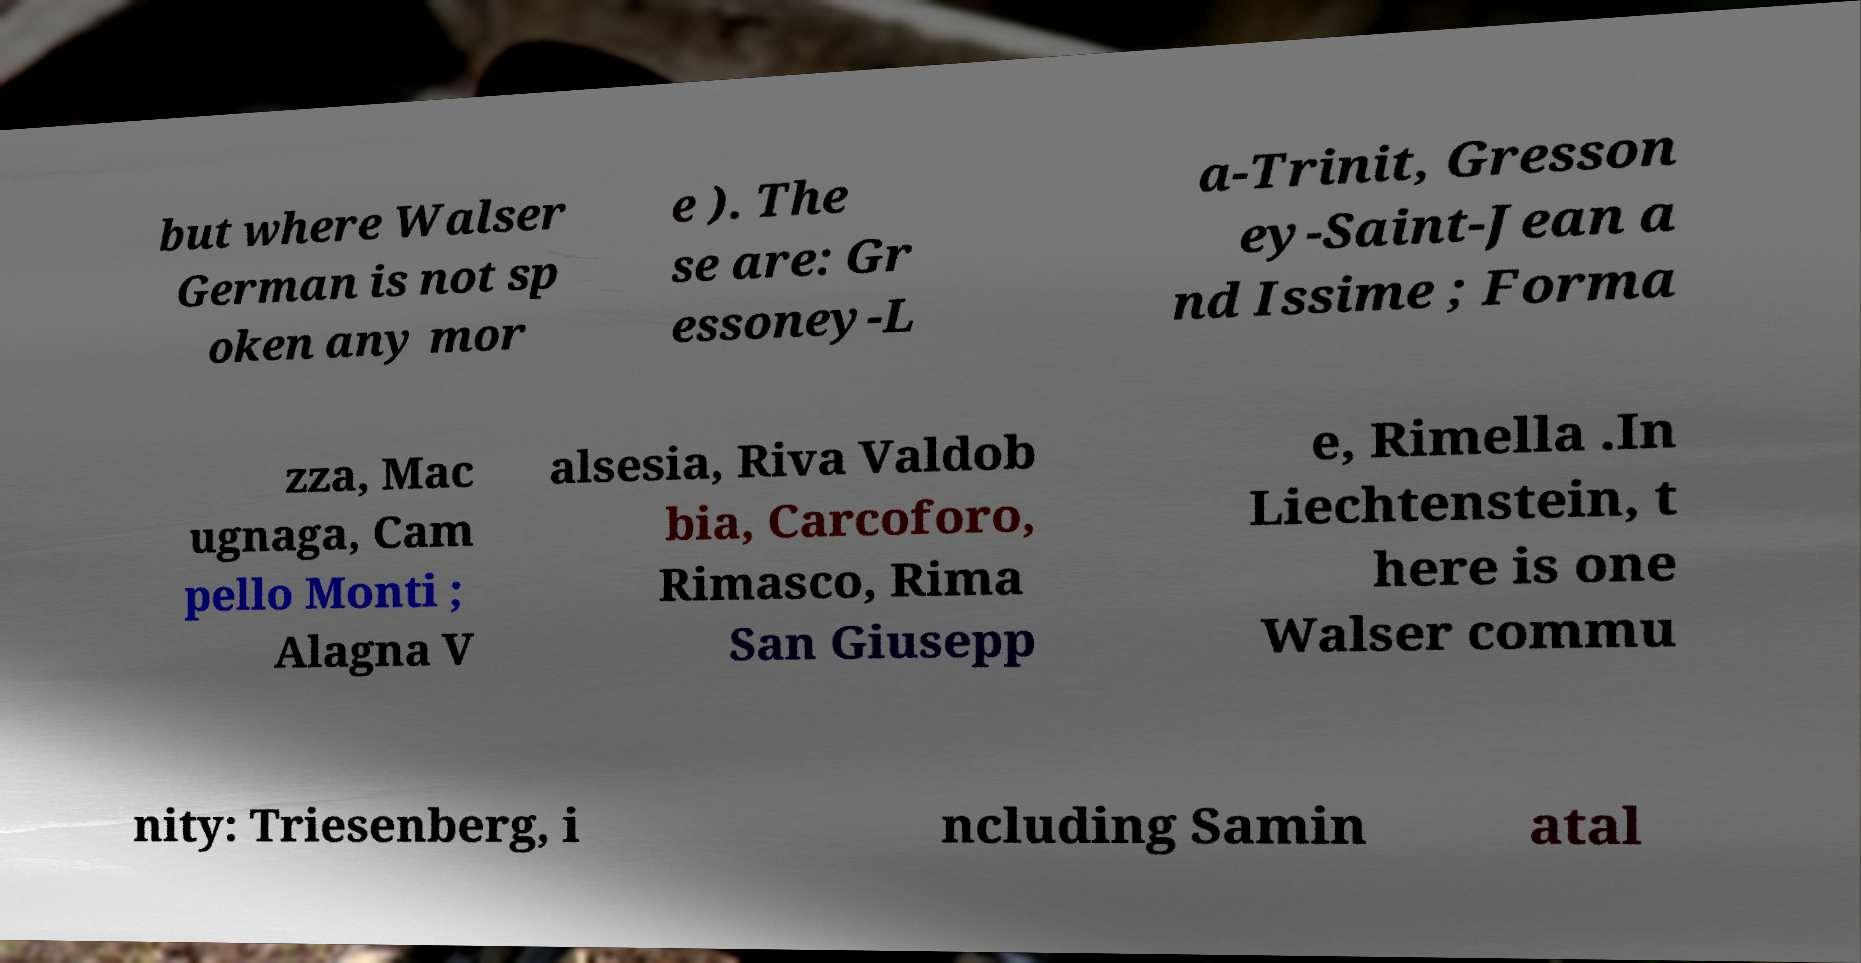What messages or text are displayed in this image? I need them in a readable, typed format. but where Walser German is not sp oken any mor e ). The se are: Gr essoney-L a-Trinit, Gresson ey-Saint-Jean a nd Issime ; Forma zza, Mac ugnaga, Cam pello Monti ; Alagna V alsesia, Riva Valdob bia, Carcoforo, Rimasco, Rima San Giusepp e, Rimella .In Liechtenstein, t here is one Walser commu nity: Triesenberg, i ncluding Samin atal 